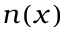<formula> <loc_0><loc_0><loc_500><loc_500>n ( x )</formula> 